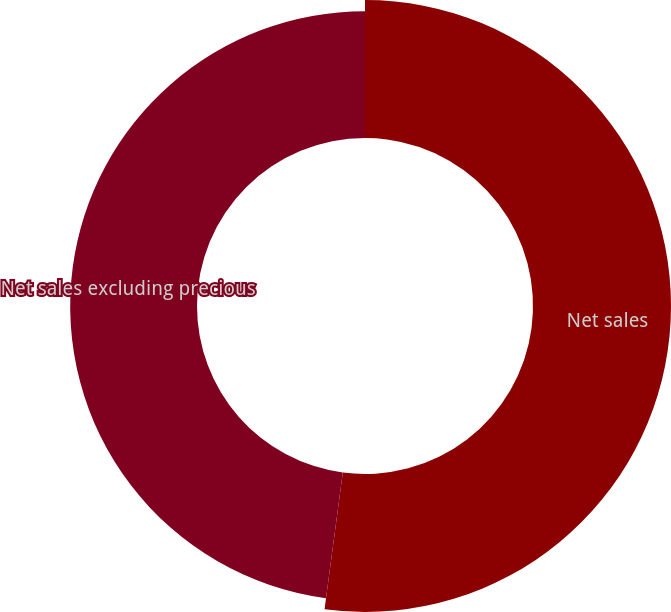Convert chart. <chart><loc_0><loc_0><loc_500><loc_500><pie_chart><fcel>Net sales<fcel>Net sales excluding precious<nl><fcel>52.11%<fcel>47.89%<nl></chart> 